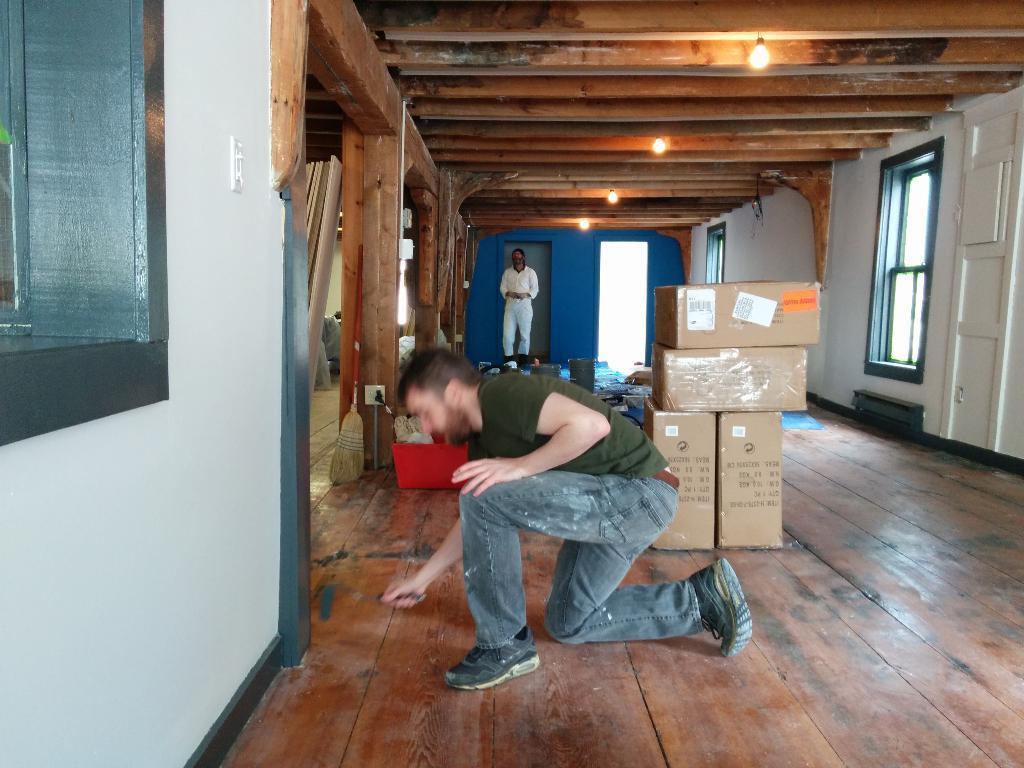Describe this image in one or two sentences. In this image we can see few people. There are few boxes and few other objects on the floor. There is a window at the left side of the image. There are few lights in the image. 